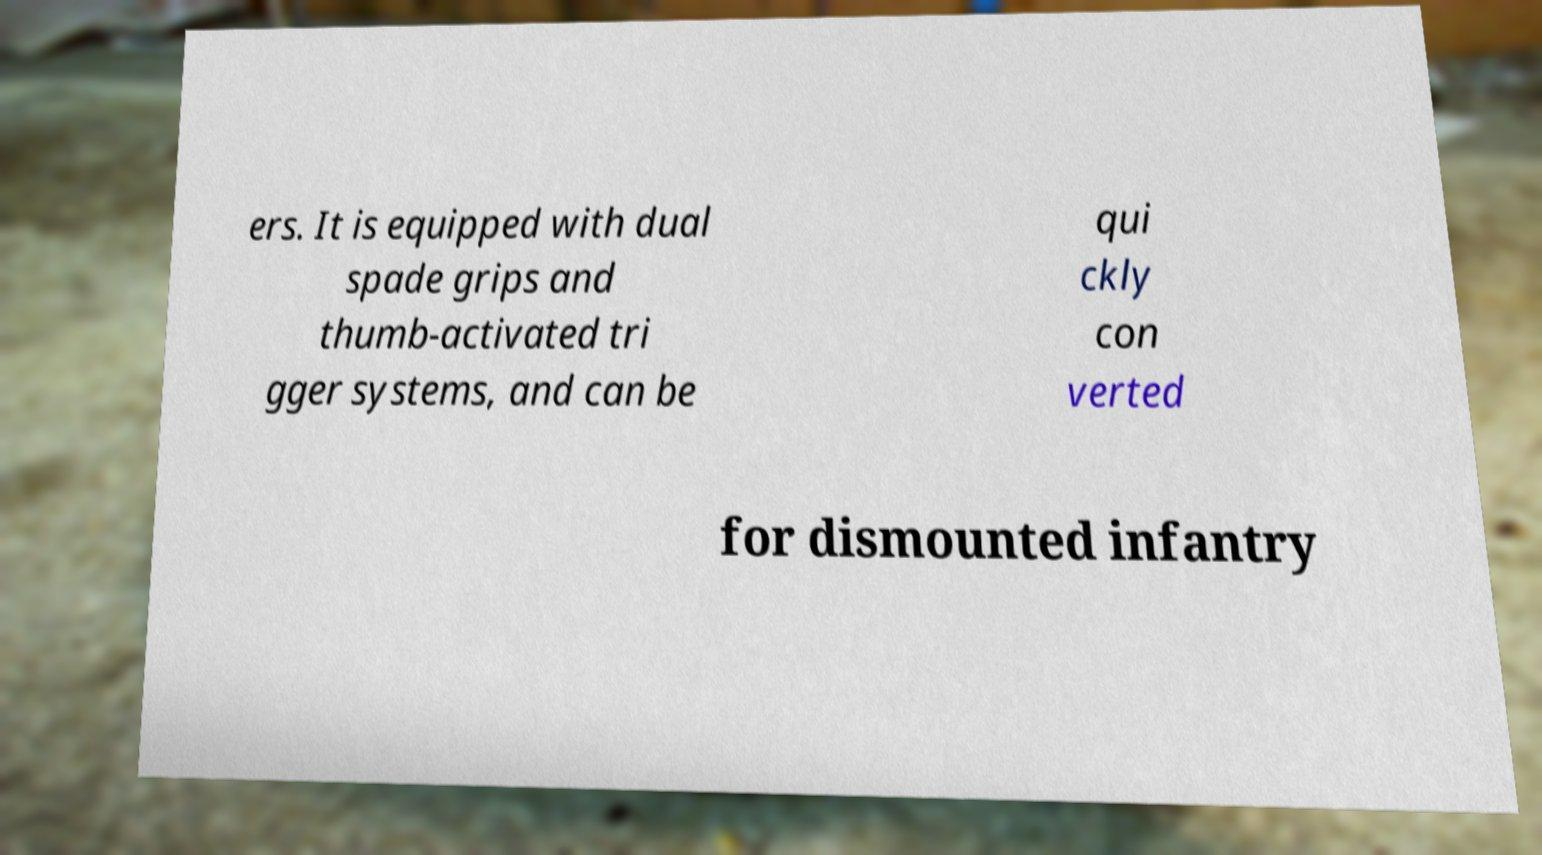What messages or text are displayed in this image? I need them in a readable, typed format. ers. It is equipped with dual spade grips and thumb-activated tri gger systems, and can be qui ckly con verted for dismounted infantry 